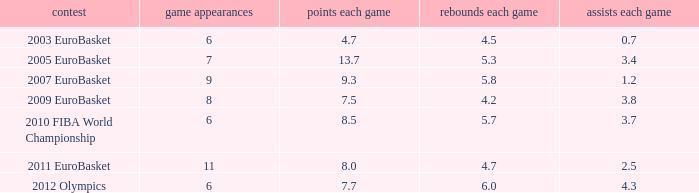How many assists per game have 4.2 rebounds per game? 3.8. 